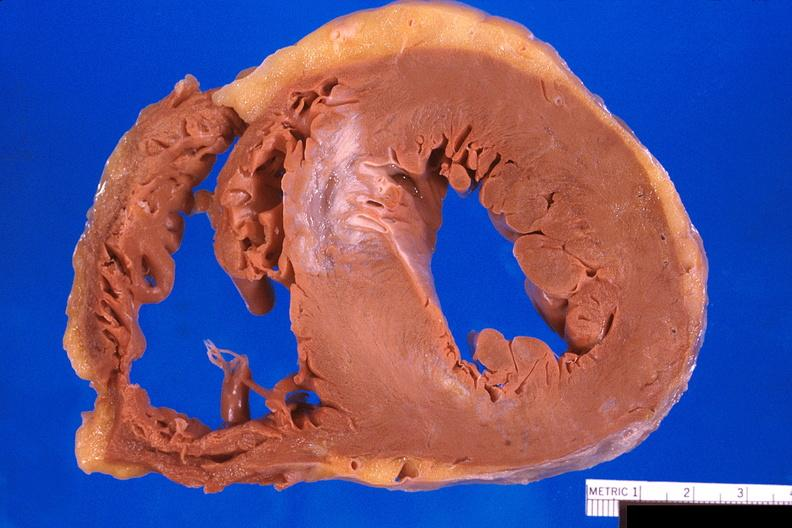what does this image show?
Answer the question using a single word or phrase. Heart 